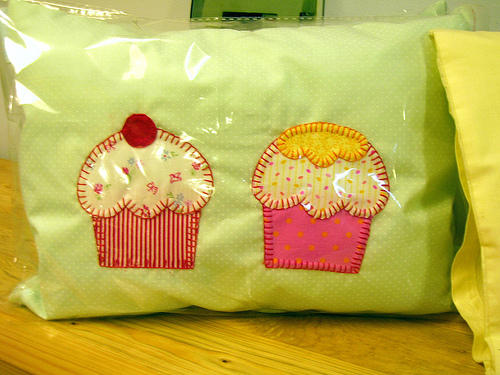<image>
Can you confirm if the cupcake is on the pillow? Yes. Looking at the image, I can see the cupcake is positioned on top of the pillow, with the pillow providing support. 